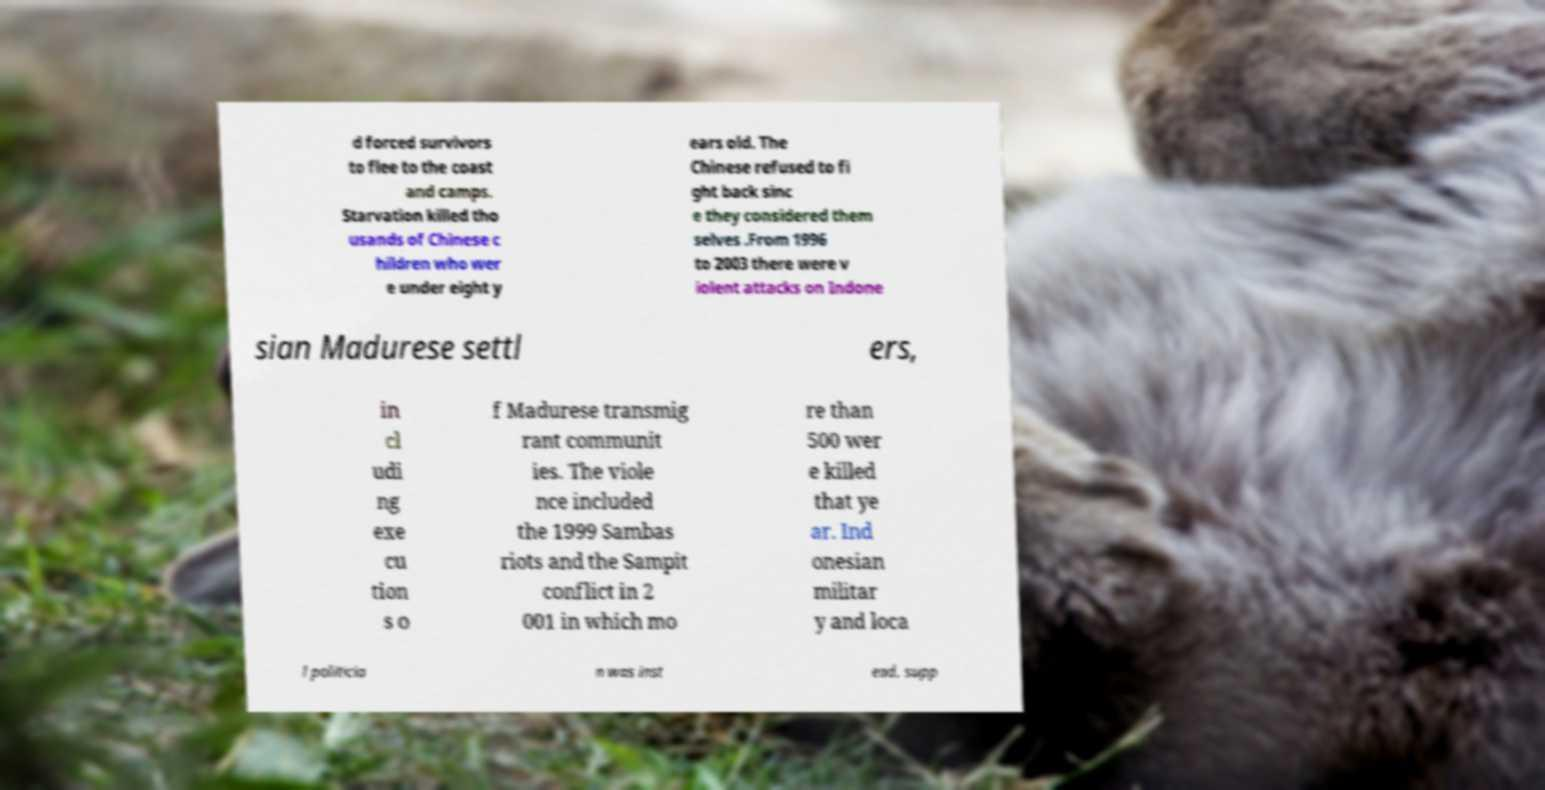For documentation purposes, I need the text within this image transcribed. Could you provide that? d forced survivors to flee to the coast and camps. Starvation killed tho usands of Chinese c hildren who wer e under eight y ears old. The Chinese refused to fi ght back sinc e they considered them selves .From 1996 to 2003 there were v iolent attacks on Indone sian Madurese settl ers, in cl udi ng exe cu tion s o f Madurese transmig rant communit ies. The viole nce included the 1999 Sambas riots and the Sampit conflict in 2 001 in which mo re than 500 wer e killed that ye ar. Ind onesian militar y and loca l politicia n was inst ead, supp 